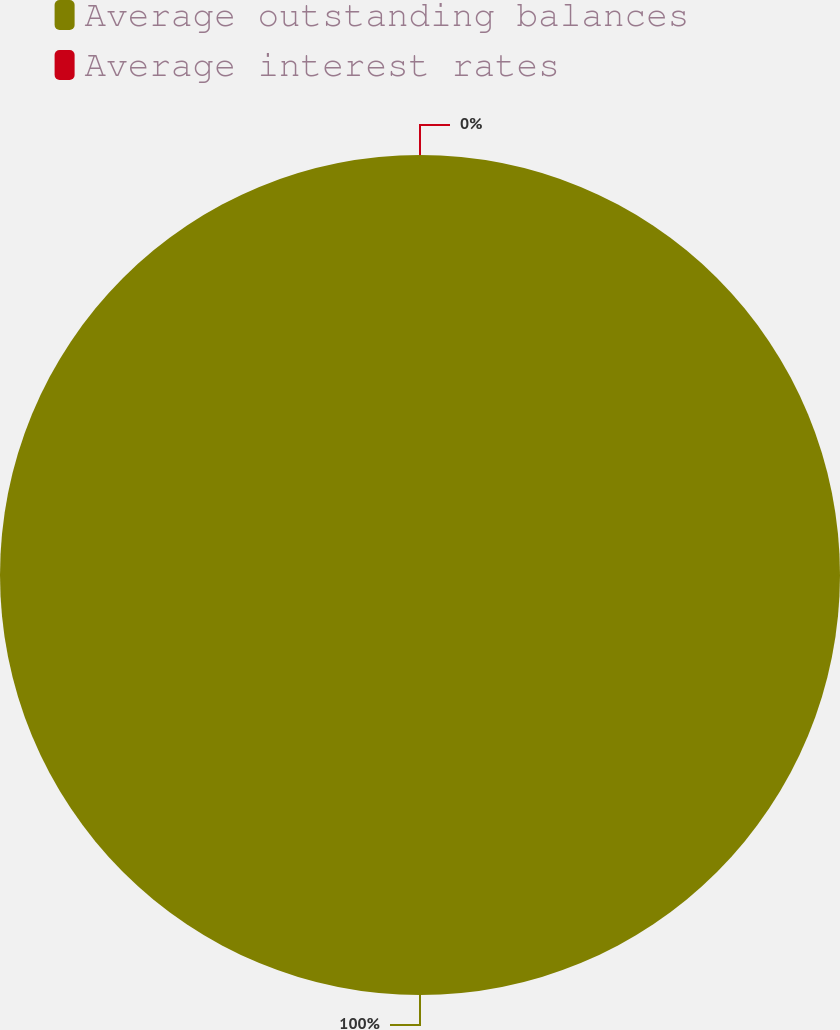<chart> <loc_0><loc_0><loc_500><loc_500><pie_chart><fcel>Average outstanding balances<fcel>Average interest rates<nl><fcel>100.0%<fcel>0.0%<nl></chart> 